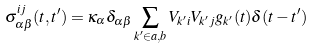<formula> <loc_0><loc_0><loc_500><loc_500>\sigma ^ { i j } _ { \alpha \beta } ( t , t ^ { \prime } ) = \kappa _ { \alpha } \delta _ { \alpha \beta } \sum _ { k ^ { \prime } \in a , b } V _ { k ^ { \prime } i } V _ { k ^ { \prime } j } g _ { k ^ { \prime } } ( t ) \delta ( t - t ^ { \prime } )</formula> 